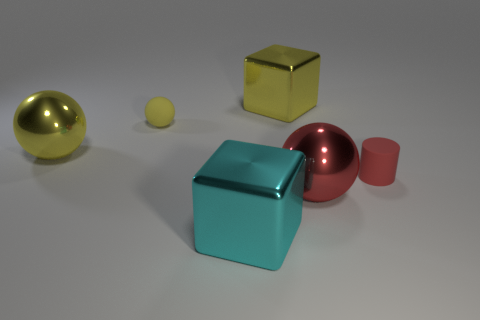Are there any other yellow spheres made of the same material as the large yellow ball?
Offer a terse response. No. The object that is the same color as the small cylinder is what size?
Your response must be concise. Large. How many cylinders are matte objects or large yellow things?
Make the answer very short. 1. Is the number of big metal spheres on the left side of the small sphere greater than the number of big metallic cubes left of the large cyan thing?
Your answer should be compact. Yes. How many other small cylinders are the same color as the cylinder?
Offer a terse response. 0. What size is the yellow cube that is the same material as the red ball?
Make the answer very short. Large. What number of things are either yellow spheres in front of the matte ball or purple spheres?
Your answer should be compact. 1. There is a metal ball behind the tiny rubber cylinder; is its color the same as the small cylinder?
Make the answer very short. No. What is the size of the yellow metallic thing that is the same shape as the large red metal object?
Offer a terse response. Large. There is a ball on the right side of the large yellow metallic block that is behind the small cylinder in front of the matte ball; what is its color?
Give a very brief answer. Red. 